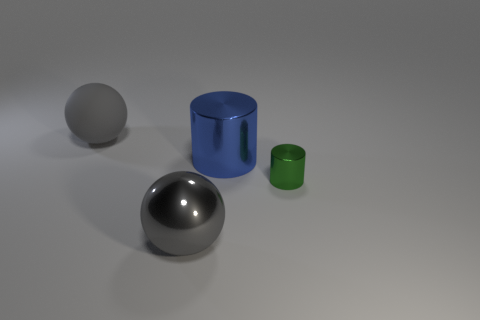Add 4 large gray rubber spheres. How many objects exist? 8 Subtract 1 cylinders. How many cylinders are left? 1 Subtract all yellow spheres. Subtract all purple cylinders. How many spheres are left? 2 Subtract all cyan cylinders. How many purple spheres are left? 0 Subtract all big spheres. Subtract all big rubber spheres. How many objects are left? 1 Add 4 blue metallic cylinders. How many blue metallic cylinders are left? 5 Add 3 big green rubber cylinders. How many big green rubber cylinders exist? 3 Subtract 2 gray balls. How many objects are left? 2 